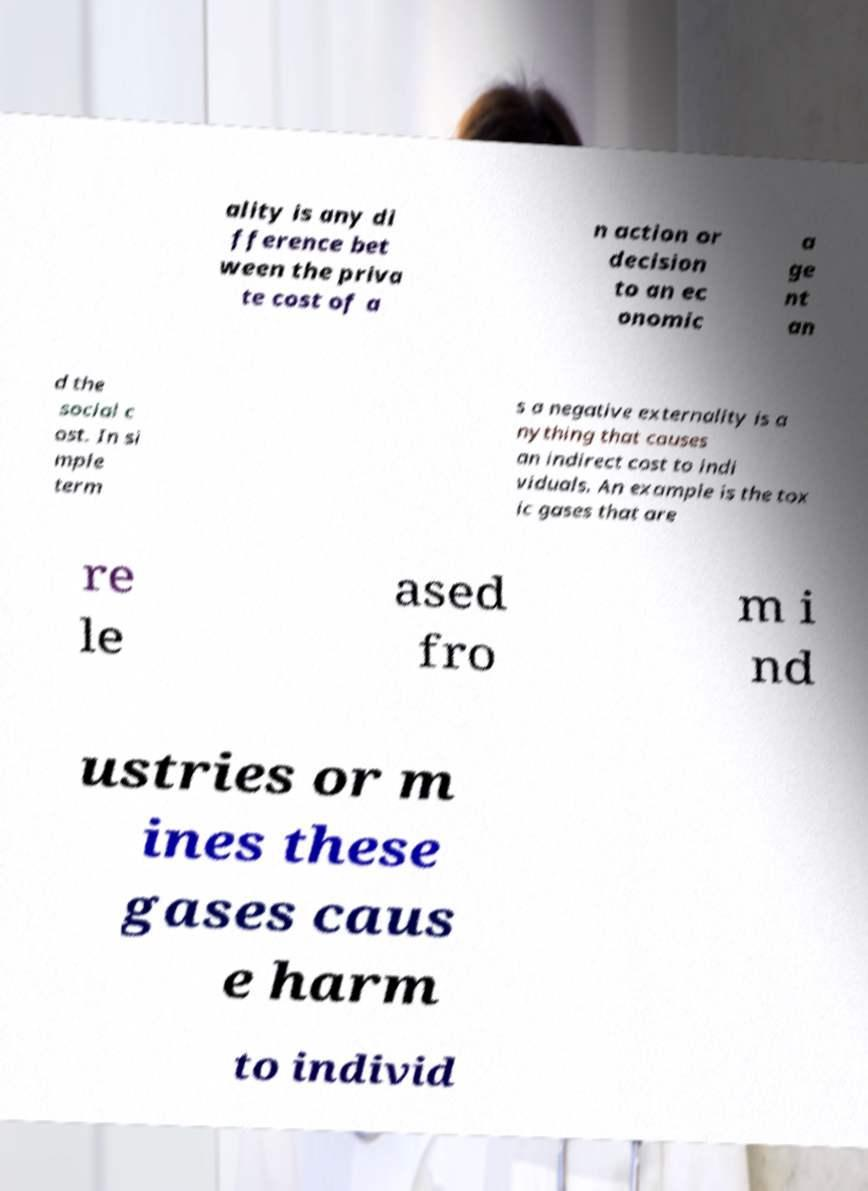What messages or text are displayed in this image? I need them in a readable, typed format. ality is any di fference bet ween the priva te cost of a n action or decision to an ec onomic a ge nt an d the social c ost. In si mple term s a negative externality is a nything that causes an indirect cost to indi viduals. An example is the tox ic gases that are re le ased fro m i nd ustries or m ines these gases caus e harm to individ 